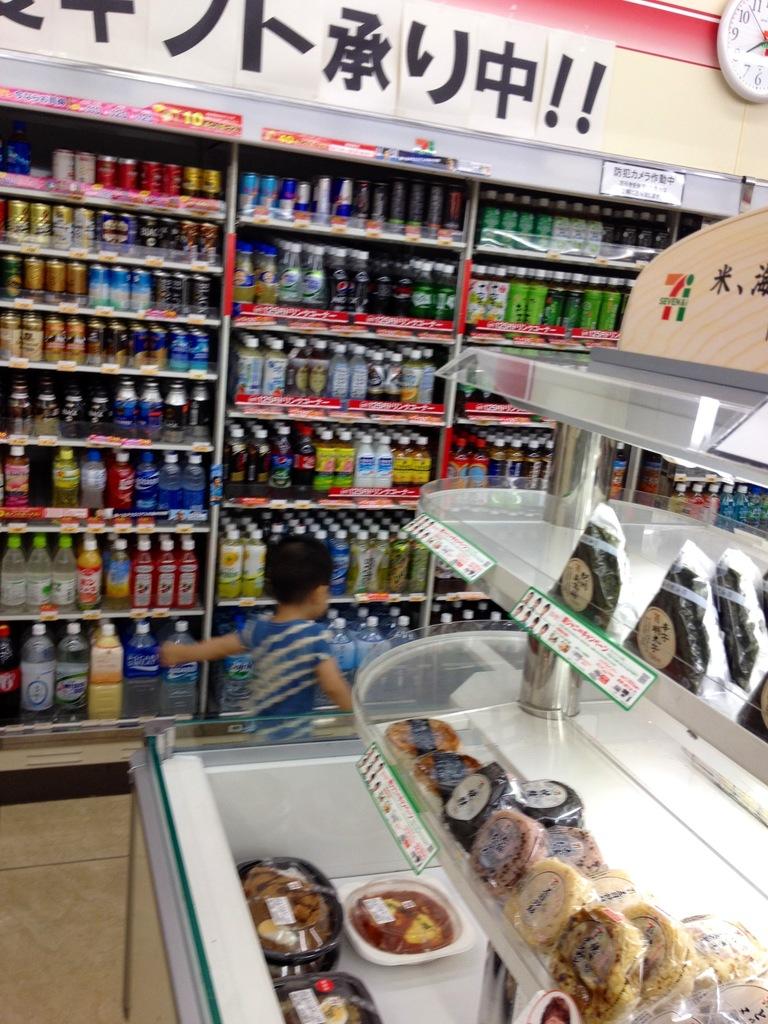Is that text in english?
Make the answer very short. No. 